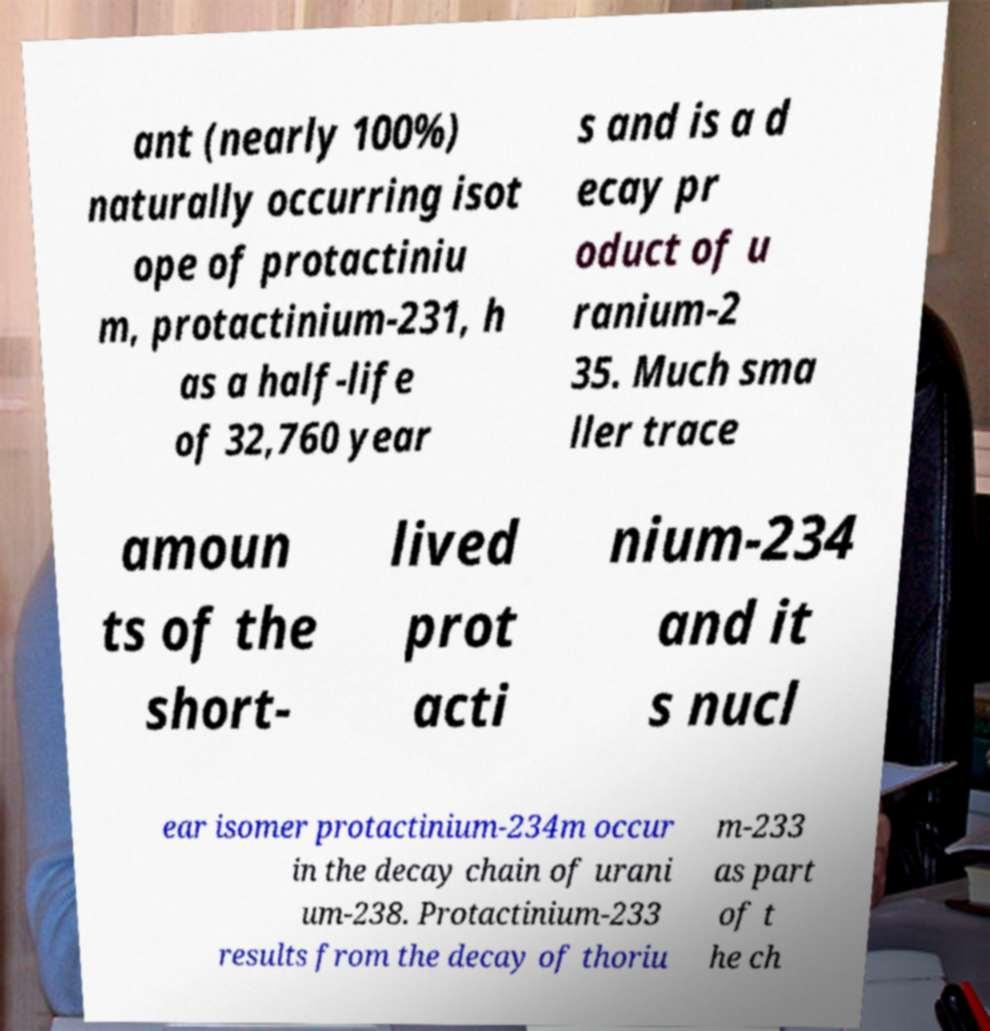Please identify and transcribe the text found in this image. ant (nearly 100%) naturally occurring isot ope of protactiniu m, protactinium-231, h as a half-life of 32,760 year s and is a d ecay pr oduct of u ranium-2 35. Much sma ller trace amoun ts of the short- lived prot acti nium-234 and it s nucl ear isomer protactinium-234m occur in the decay chain of urani um-238. Protactinium-233 results from the decay of thoriu m-233 as part of t he ch 